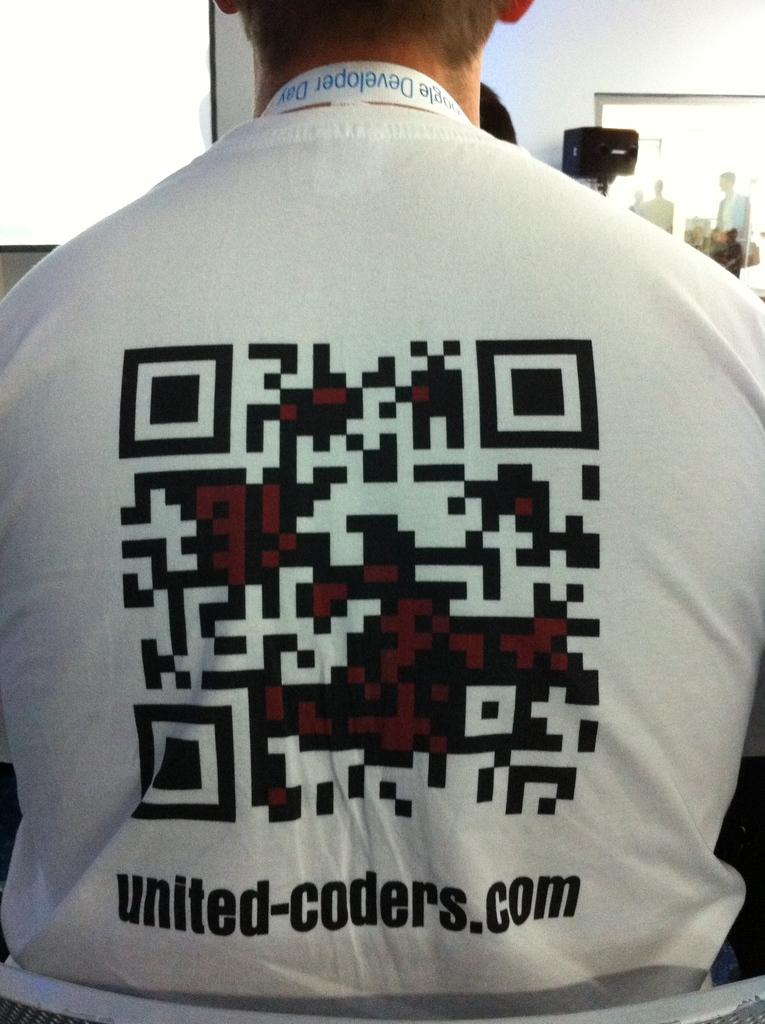Who or what is present in the image? There is a person in the image. What is the person wearing? The person is wearing a white shirt. Are there any specific details about the shirt? Yes, there is writing on the shirt. What is the background of the image? There is a white wall in front of the person. How many cows can be seen grazing in front of the person in the image? There are no cows present in the image; it features a person standing in front of a white wall. 